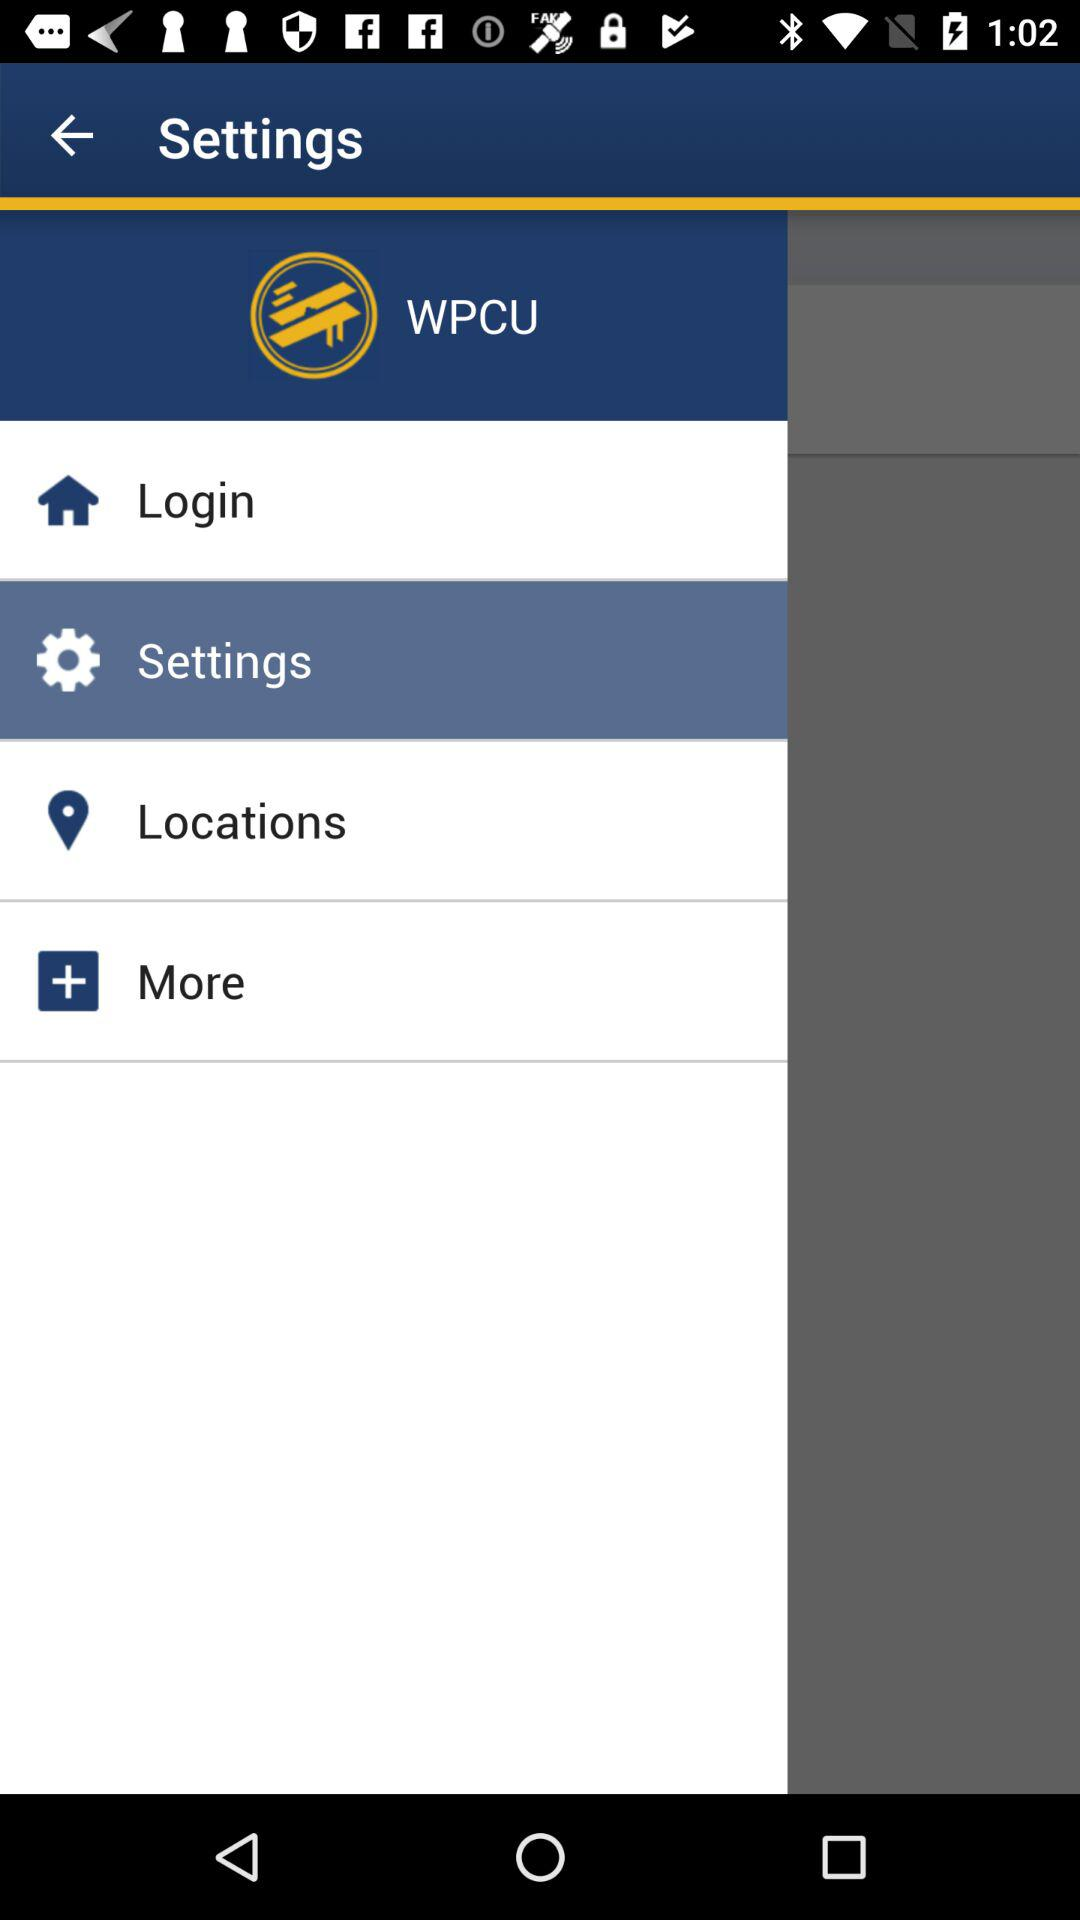What is the name of the application? The name of the application is "WPCU". 